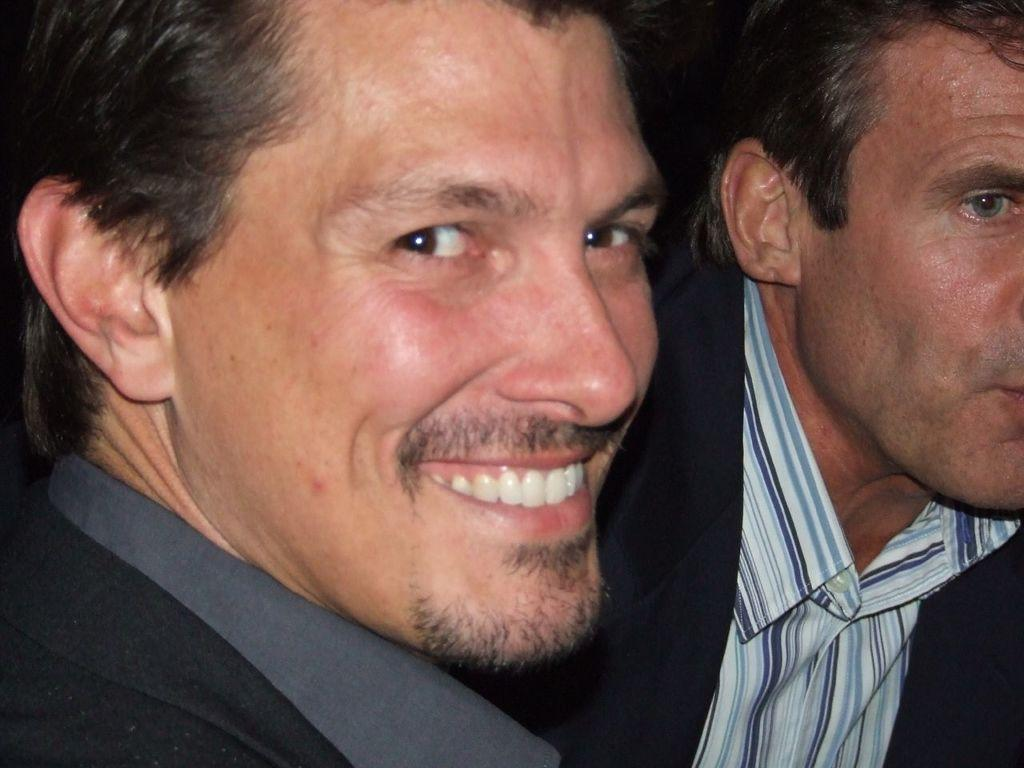How many people are in the image? There are two men in the image. What are the men wearing on their upper bodies? The men are wearing suits and shirts. What type of joke is the man on the left telling in the image? There is no indication of a joke being told in the image; the men are simply wearing suits and shirts. Can you tell me where the men bought their suits from in the image? There is no information about where the men bought their suits in the image. 